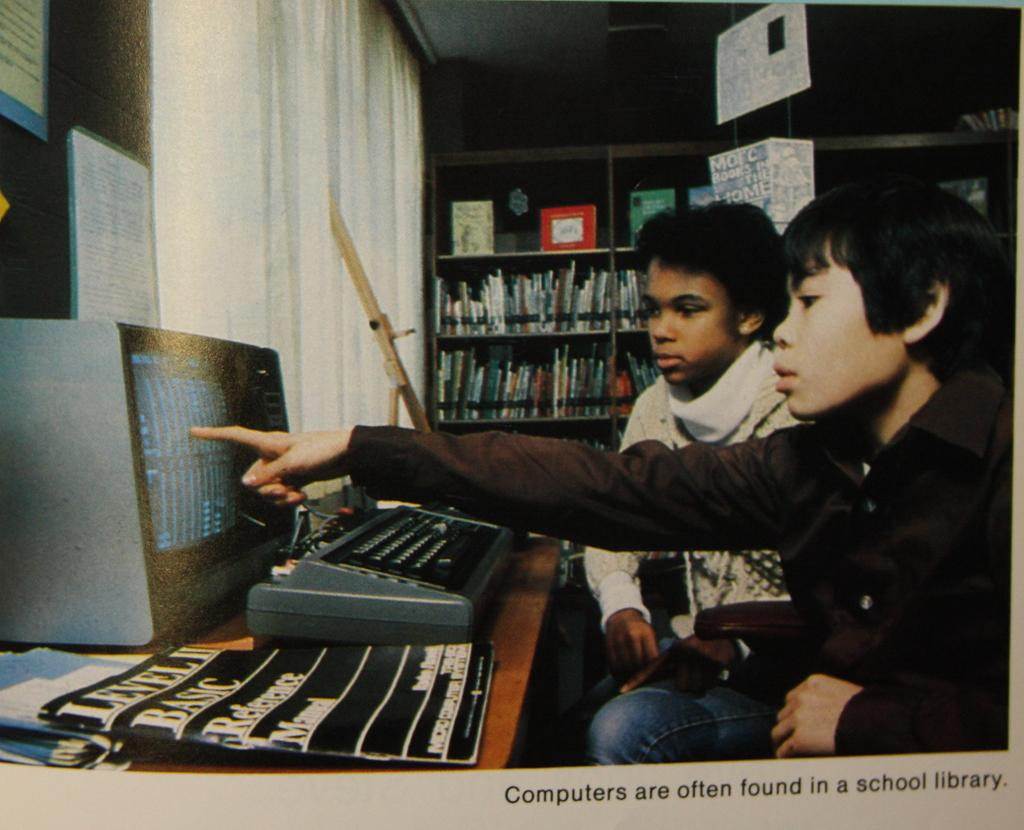<image>
Render a clear and concise summary of the photo. A photo of two boys that is captioned Computers are often found in a school library. 